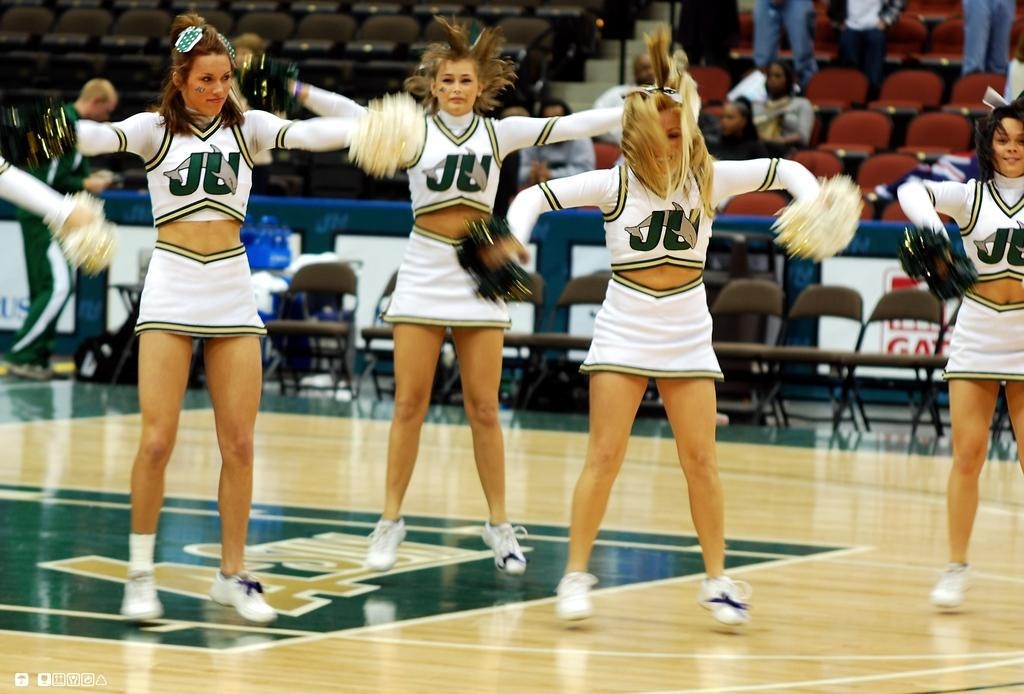<image>
Render a clear and concise summary of the photo. An image of at least five cheerleaders performing from JU. 